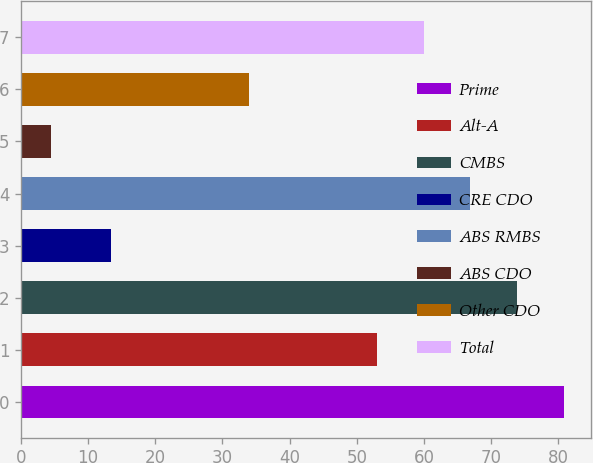Convert chart to OTSL. <chart><loc_0><loc_0><loc_500><loc_500><bar_chart><fcel>Prime<fcel>Alt-A<fcel>CMBS<fcel>CRE CDO<fcel>ABS RMBS<fcel>ABS CDO<fcel>Other CDO<fcel>Total<nl><fcel>80.8<fcel>53<fcel>73.85<fcel>13.4<fcel>66.9<fcel>4.4<fcel>33.9<fcel>59.95<nl></chart> 